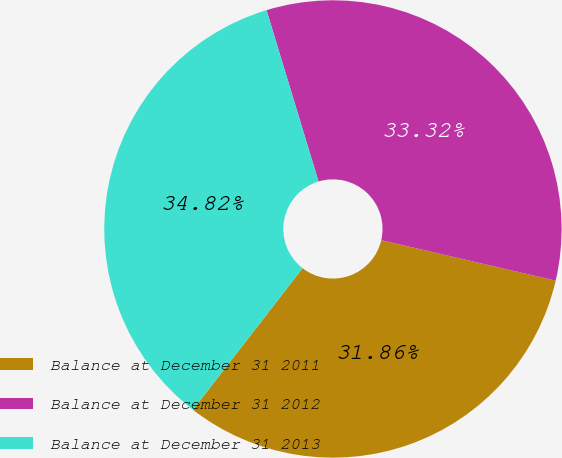<chart> <loc_0><loc_0><loc_500><loc_500><pie_chart><fcel>Balance at December 31 2011<fcel>Balance at December 31 2012<fcel>Balance at December 31 2013<nl><fcel>31.86%<fcel>33.32%<fcel>34.82%<nl></chart> 